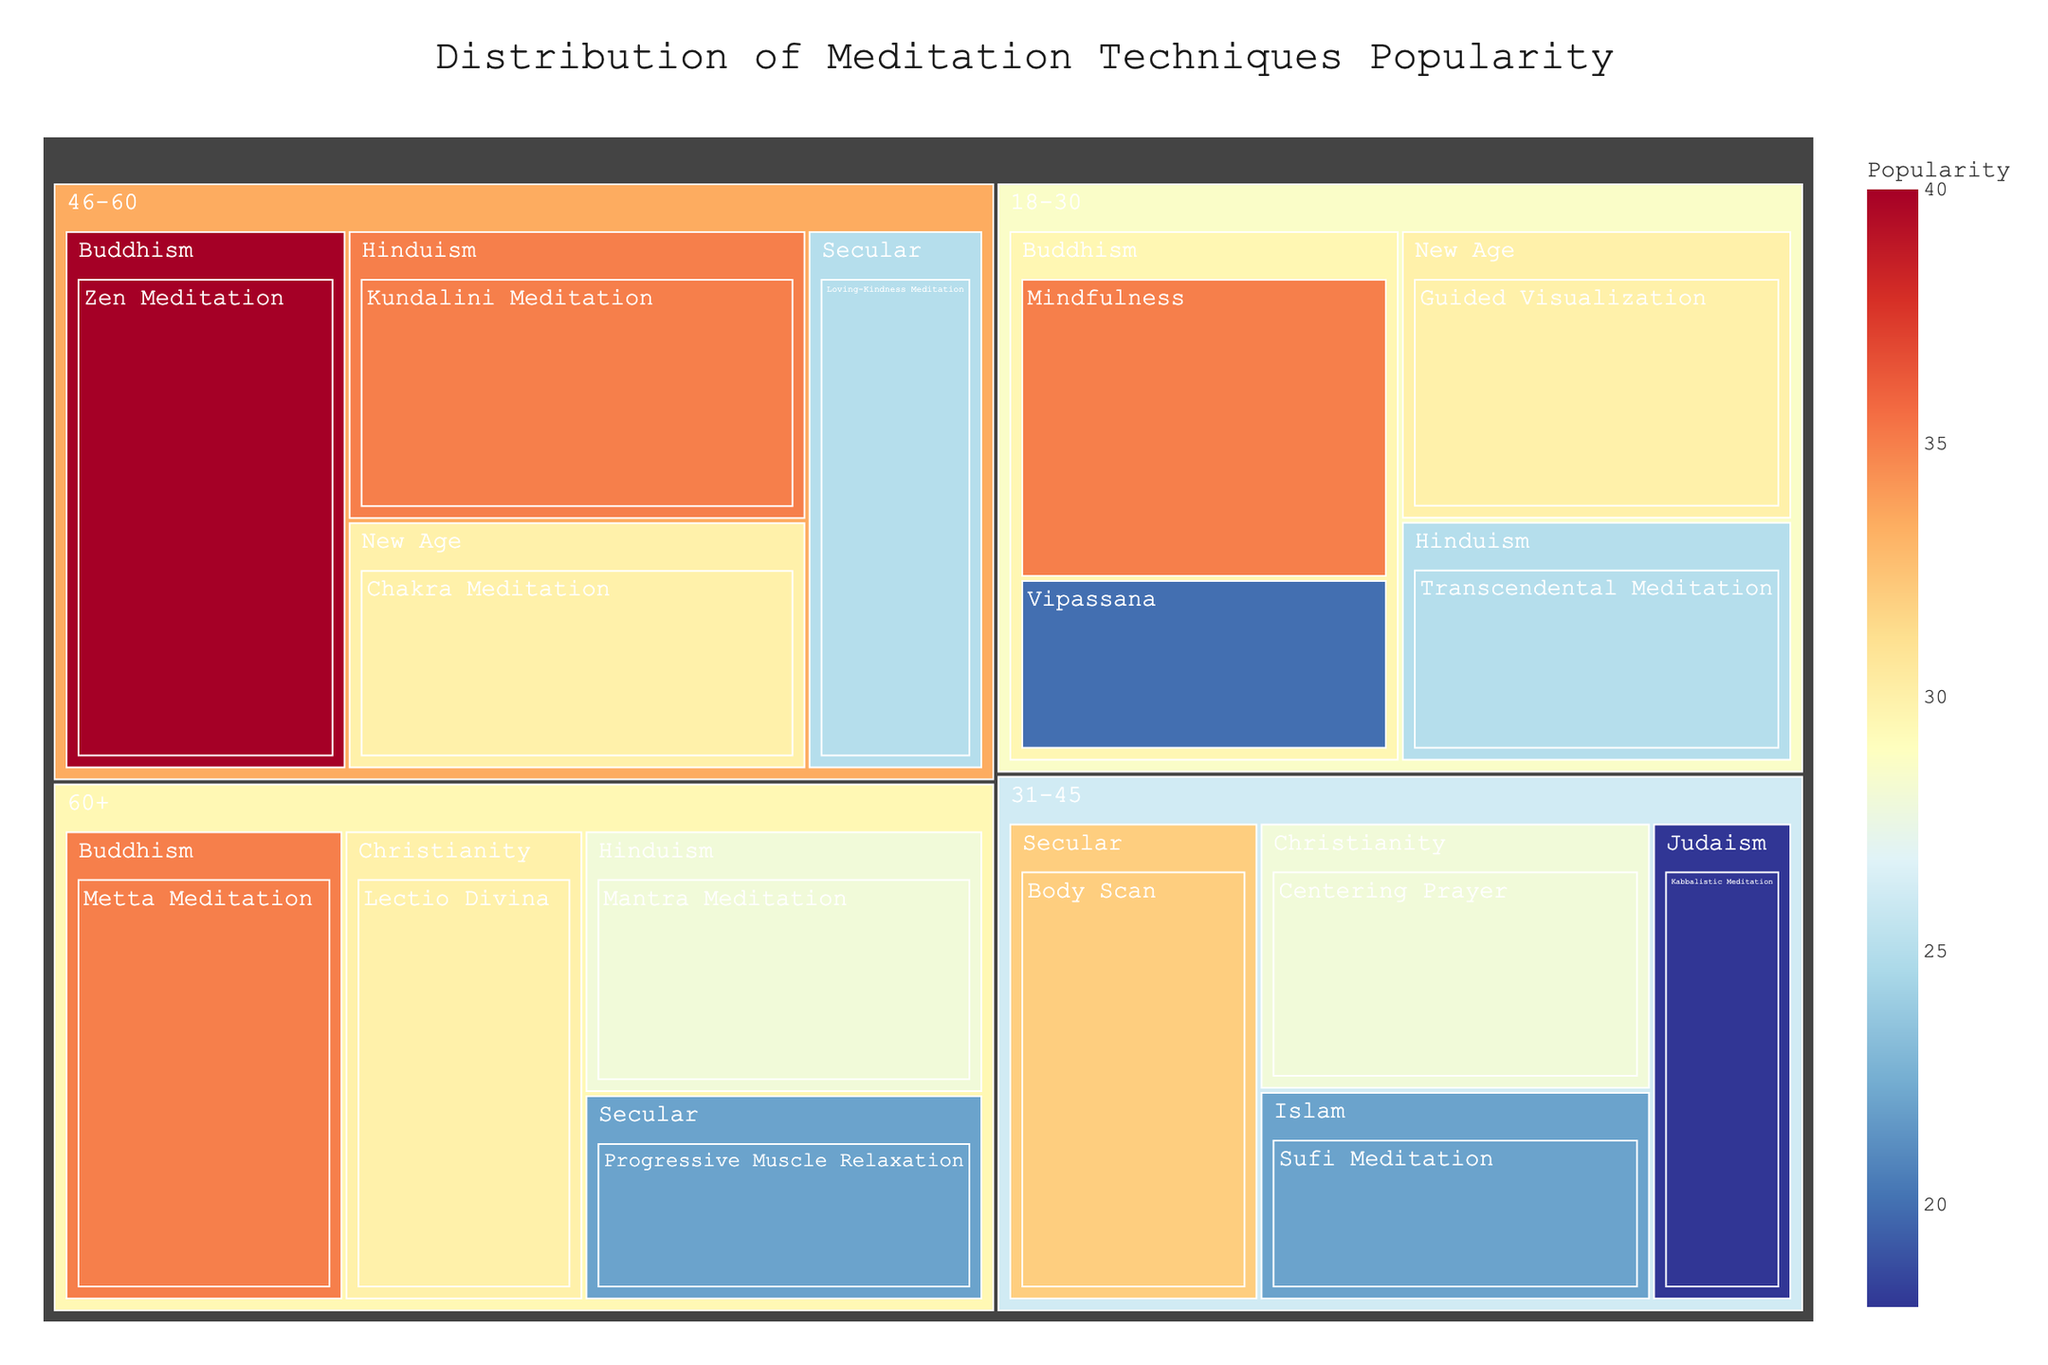What is the most popular meditation technique for people aged 46-60 with a Buddhist background? This is a basic question. Look for the age group 46-60, then find the Buddhist background and identify the meditation technique with the highest popularity value.
Answer: Zen Meditation Which age group has the highest popularity for Transcendental Meditation under Hinduism? This is a comparison question. Locate all instances of Transcendental Meditation under Hinduism and compare the popularity values for each age group.
Answer: 18-30 What is the total popularity of Centering Prayer and Lectio Divina? This is a compositional question requiring addition. Find the popularity values for Centering Prayer and Lectio Divina and sum them up: 28 + 30 = 58.
Answer: 58 Among the New Age spiritual background, which meditation technique is popular in the age group 18-30? This is a basic question. Look for the New Age background within the 18-30 age group and identify the meditation technique.
Answer: Guided Visualization Which spiritual background in the 31-45 age group has the lowest popularity for their respective meditation technique? This is a comparison question. Look at the 31-45 age group and compare the popularity values across different spiritual backgrounds to identify the lowest value.
Answer: Judaism How does the popularity of Metta Meditation in the 60+ age group under Buddhism compare with Mindfulness in 18-30 under Buddhism? This is a comparison question. Compare the popularity values of Metta Meditation (35) and Mindfulness (35) between these age groups within Buddhism.
Answer: Equal What's the average popularity of meditation techniques across all spiritual backgrounds for 18-30 age group? This is a compositional question requiring the calculation of the mean. Add up all popularity values in the 18-30 age group and divide by the number of techniques: (35+20+25+30) / 4 = 27.5
Answer: 27.5 Which meditation technique has the highest popularity in the dataset? This is a chart-type specific question. Scan the entire treemap to find the meditation technique with the highest popularity value.
Answer: Zen Meditation How much more popular is Kabbalistic Meditation in 31-45 compared to Transcendental Meditation in 18-30? This is a comparison question requiring subtraction. Subtract the popularity values: 25 - 18 = 7.
Answer: 7 